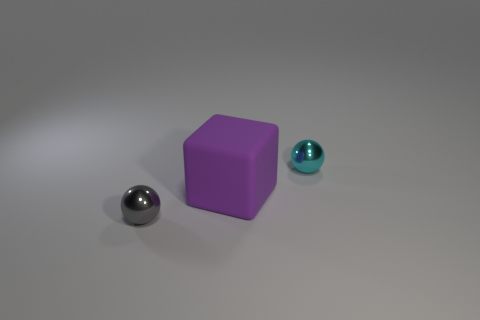Add 2 big purple rubber things. How many objects exist? 5 Subtract all cubes. How many objects are left? 2 Subtract all tiny shiny objects. Subtract all small gray balls. How many objects are left? 0 Add 2 purple matte objects. How many purple matte objects are left? 3 Add 3 small brown cylinders. How many small brown cylinders exist? 3 Subtract 1 gray balls. How many objects are left? 2 